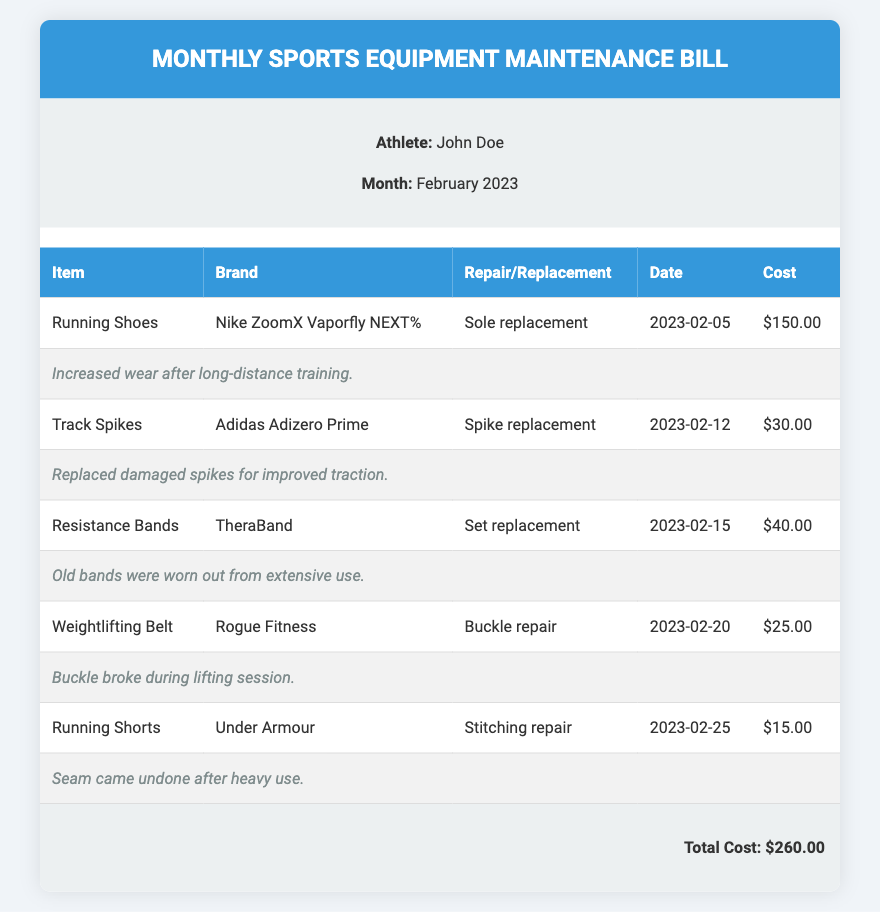What is the athlete's name? The athlete's name is stated in the document under athlete information.
Answer: John Doe What was repaired on February 5, 2023? This date is associated with the repair of the Running Shoes, as indicated in the document.
Answer: Sole replacement How much did the spike replacement for the Track Spikes cost? The cost for the spike replacement is listed in the document next to the item.
Answer: $30.00 What is the total cost of the maintenance bill? The total cost is explicitly mentioned in the document at the bottom of the bill.
Answer: $260.00 Which brand of Resistance Bands was replaced? The brand of the replaced Resistance Bands is mentioned in the document.
Answer: TheraBand What type of repair was made to the Weightlifting Belt? The document specifies the type of repair conducted on the Weightlifting Belt.
Answer: Buckle repair How many repairs or replacements were conducted in total? The document lists five items that had repairs or replacements throughout the month.
Answer: Five What is the repair note for the Running Shorts? The note pertaining to the Running Shorts is included in the detailed notes for repairs in the document.
Answer: Seam came undone after heavy use 